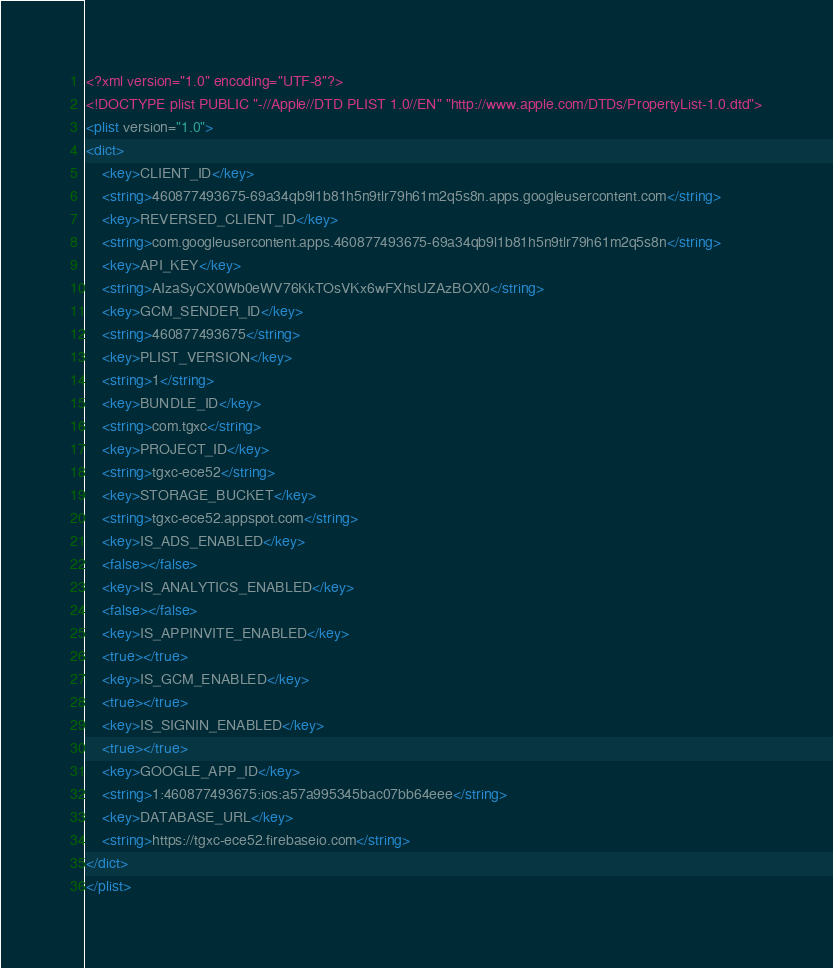<code> <loc_0><loc_0><loc_500><loc_500><_XML_><?xml version="1.0" encoding="UTF-8"?>
<!DOCTYPE plist PUBLIC "-//Apple//DTD PLIST 1.0//EN" "http://www.apple.com/DTDs/PropertyList-1.0.dtd">
<plist version="1.0">
<dict>
	<key>CLIENT_ID</key>
	<string>460877493675-69a34qb9l1b81h5n9tlr79h61m2q5s8n.apps.googleusercontent.com</string>
	<key>REVERSED_CLIENT_ID</key>
	<string>com.googleusercontent.apps.460877493675-69a34qb9l1b81h5n9tlr79h61m2q5s8n</string>
	<key>API_KEY</key>
	<string>AIzaSyCX0Wb0eWV76KkTOsVKx6wFXhsUZAzBOX0</string>
	<key>GCM_SENDER_ID</key>
	<string>460877493675</string>
	<key>PLIST_VERSION</key>
	<string>1</string>
	<key>BUNDLE_ID</key>
	<string>com.tgxc</string>
	<key>PROJECT_ID</key>
	<string>tgxc-ece52</string>
	<key>STORAGE_BUCKET</key>
	<string>tgxc-ece52.appspot.com</string>
	<key>IS_ADS_ENABLED</key>
	<false></false>
	<key>IS_ANALYTICS_ENABLED</key>
	<false></false>
	<key>IS_APPINVITE_ENABLED</key>
	<true></true>
	<key>IS_GCM_ENABLED</key>
	<true></true>
	<key>IS_SIGNIN_ENABLED</key>
	<true></true>
	<key>GOOGLE_APP_ID</key>
	<string>1:460877493675:ios:a57a995345bac07bb64eee</string>
	<key>DATABASE_URL</key>
	<string>https://tgxc-ece52.firebaseio.com</string>
</dict>
</plist></code> 